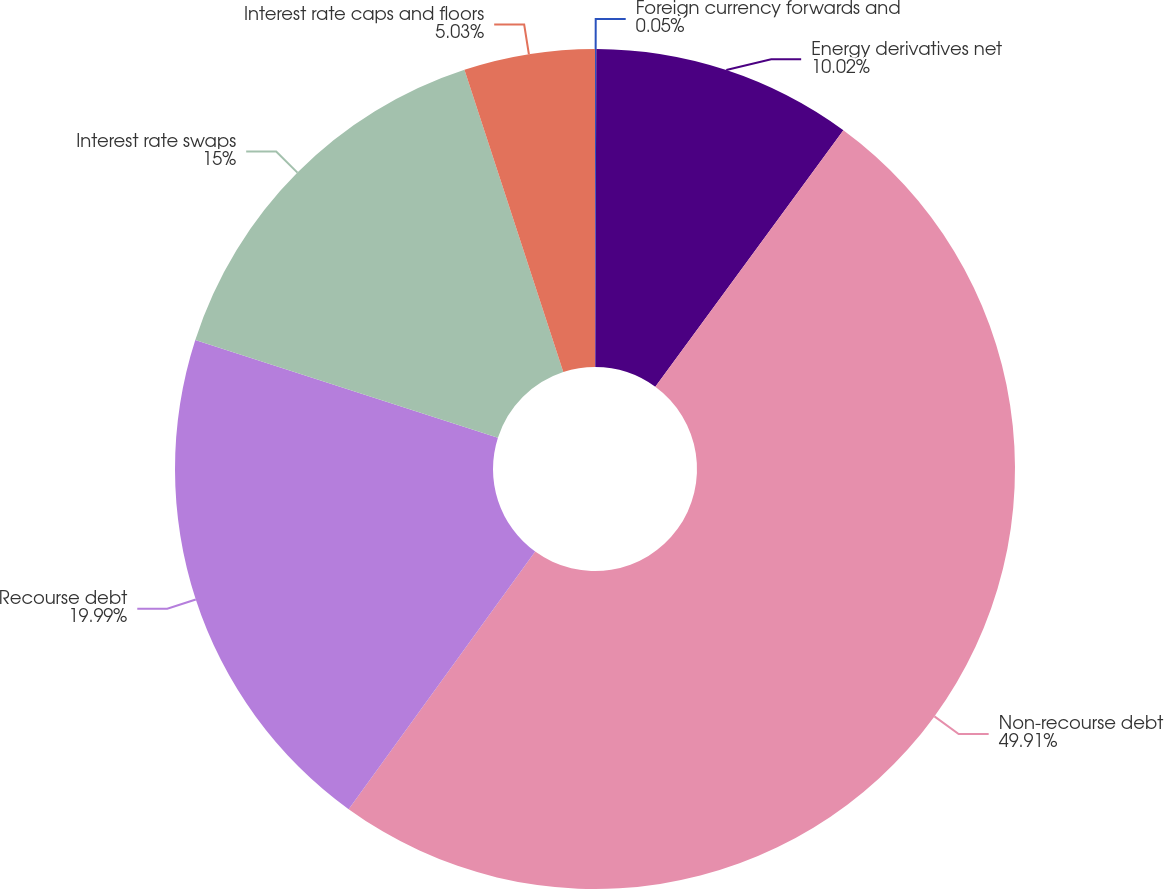Convert chart to OTSL. <chart><loc_0><loc_0><loc_500><loc_500><pie_chart><fcel>Foreign currency forwards and<fcel>Energy derivatives net<fcel>Non-recourse debt<fcel>Recourse debt<fcel>Interest rate swaps<fcel>Interest rate caps and floors<nl><fcel>0.05%<fcel>10.02%<fcel>49.9%<fcel>19.99%<fcel>15.0%<fcel>5.03%<nl></chart> 